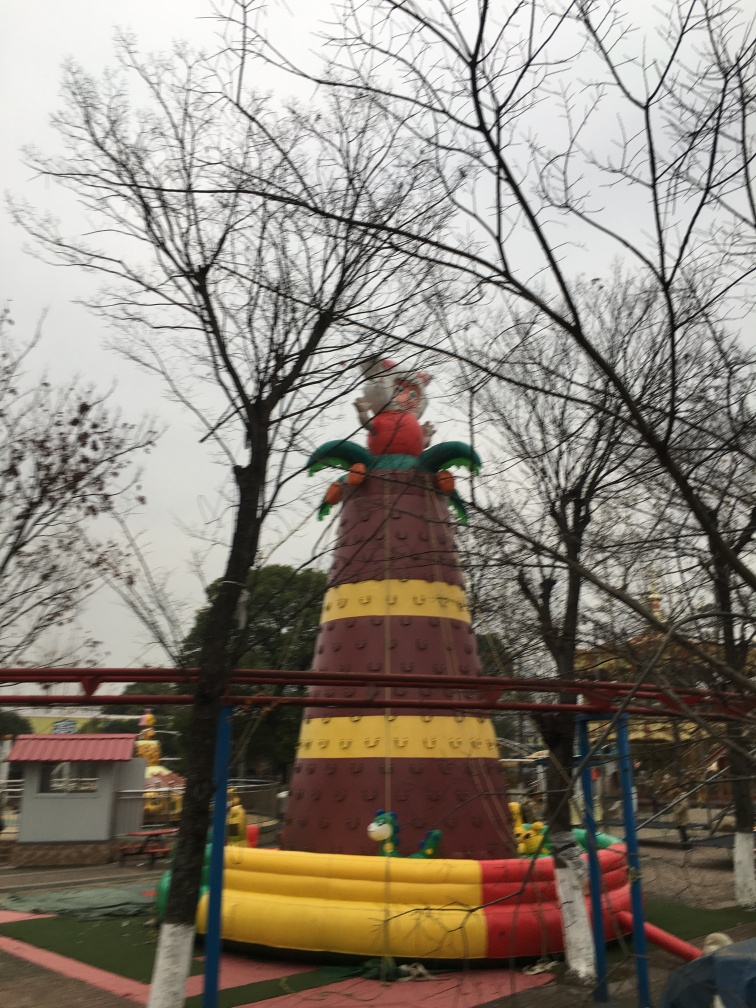What is the structure depicted in the image? It appears to be a large inflatable play structure, possibly part of a children's play area in a park. 